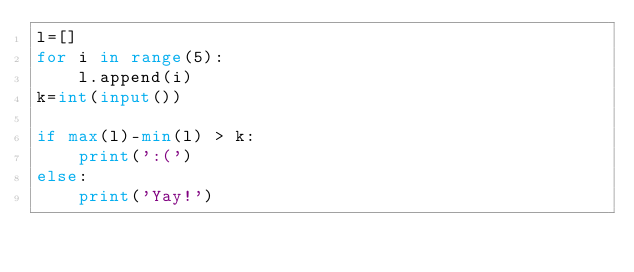<code> <loc_0><loc_0><loc_500><loc_500><_Python_>l=[]
for i in range(5):
    l.append(i)
k=int(input())

if max(l)-min(l) > k:
    print(':(')
else:
    print('Yay!')

</code> 